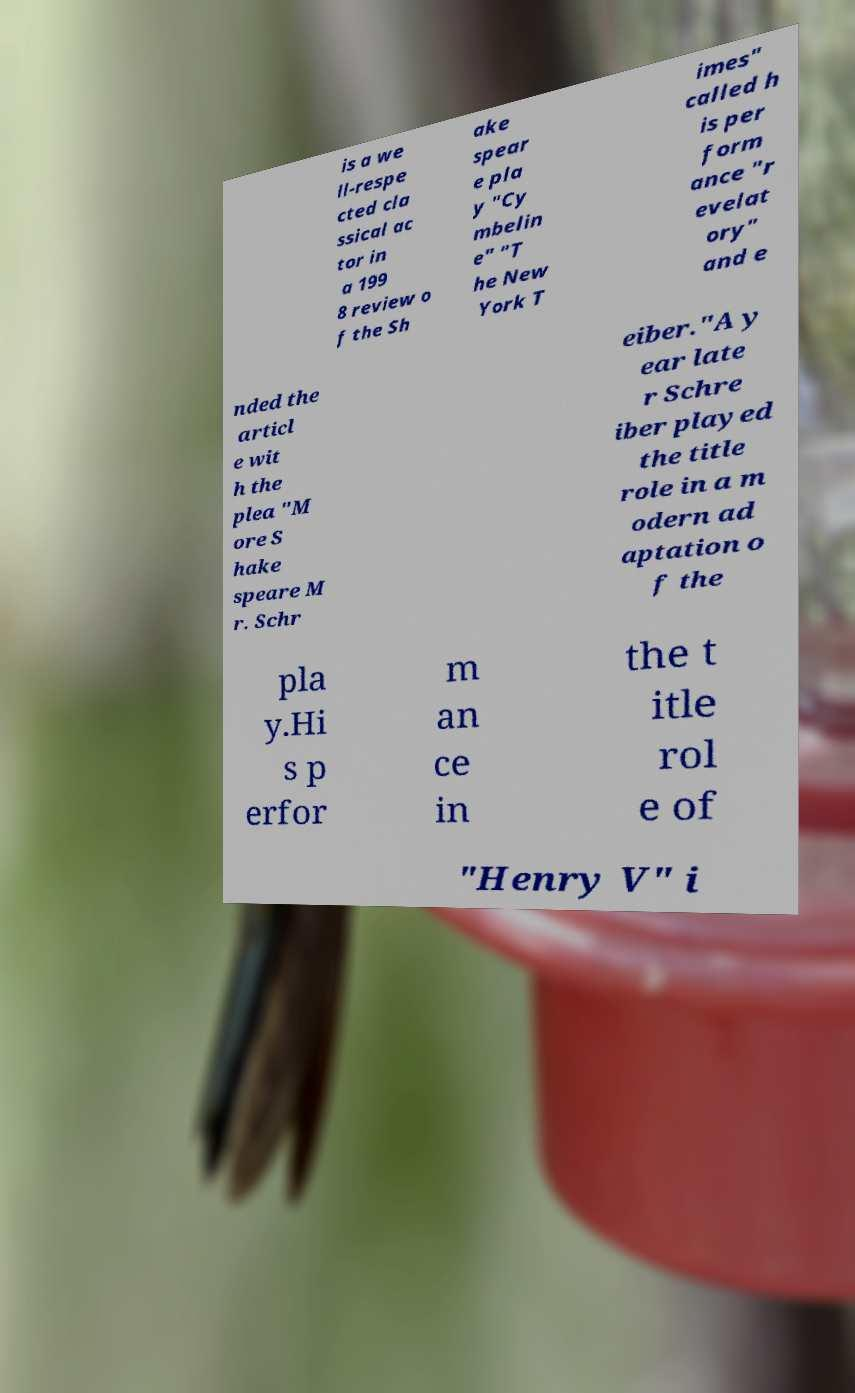Could you extract and type out the text from this image? is a we ll-respe cted cla ssical ac tor in a 199 8 review o f the Sh ake spear e pla y "Cy mbelin e" "T he New York T imes" called h is per form ance "r evelat ory" and e nded the articl e wit h the plea "M ore S hake speare M r. Schr eiber."A y ear late r Schre iber played the title role in a m odern ad aptation o f the pla y.Hi s p erfor m an ce in the t itle rol e of "Henry V" i 